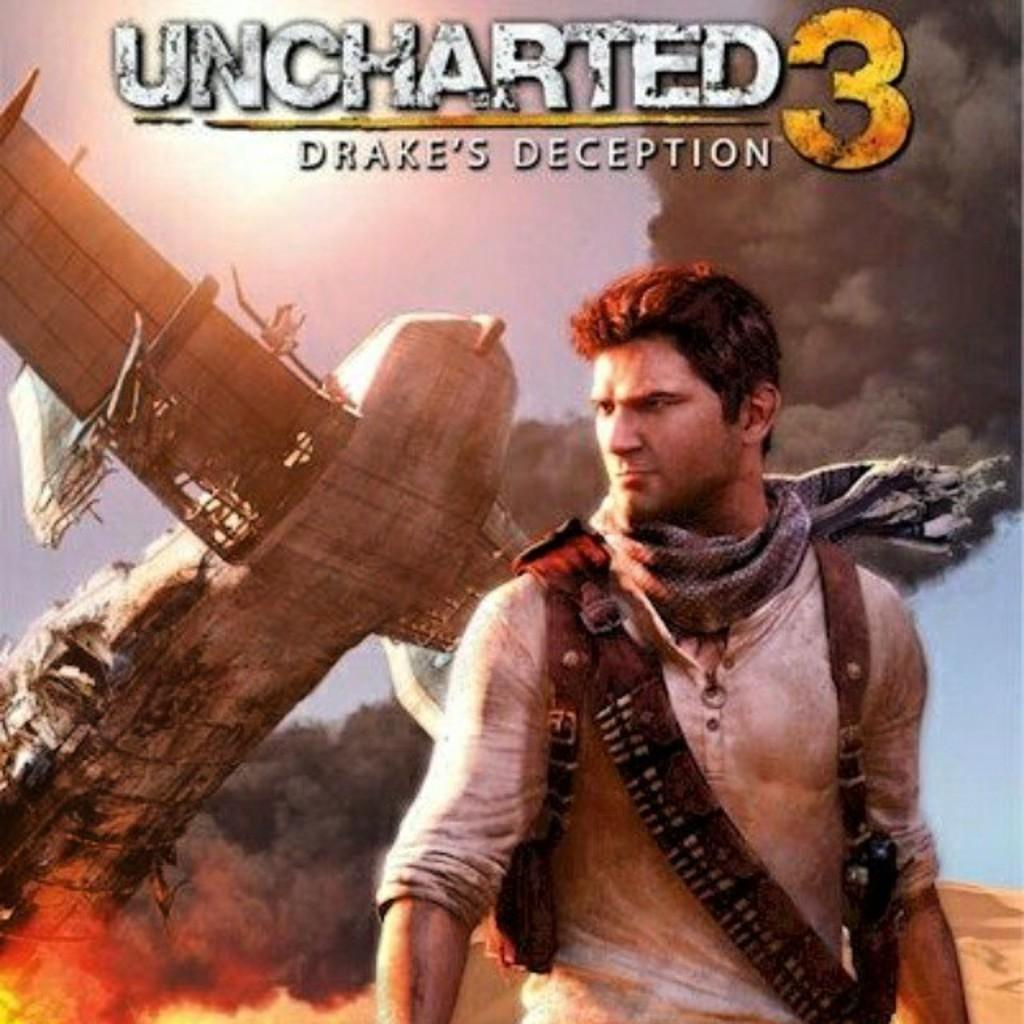<image>
Describe the image concisely. The cover of Uncharted 3 has a man wearing a scarf around his neck. 